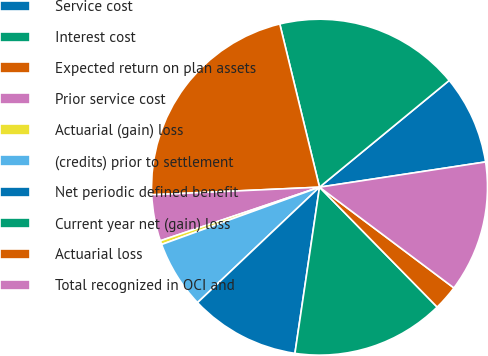Convert chart to OTSL. <chart><loc_0><loc_0><loc_500><loc_500><pie_chart><fcel>Service cost<fcel>Interest cost<fcel>Expected return on plan assets<fcel>Prior service cost<fcel>Actuarial (gain) loss<fcel>(credits) prior to settlement<fcel>Net periodic defined benefit<fcel>Current year net (gain) loss<fcel>Actuarial loss<fcel>Total recognized in OCI and<nl><fcel>8.56%<fcel>17.84%<fcel>21.92%<fcel>4.45%<fcel>0.37%<fcel>6.52%<fcel>10.6%<fcel>14.69%<fcel>2.41%<fcel>12.64%<nl></chart> 